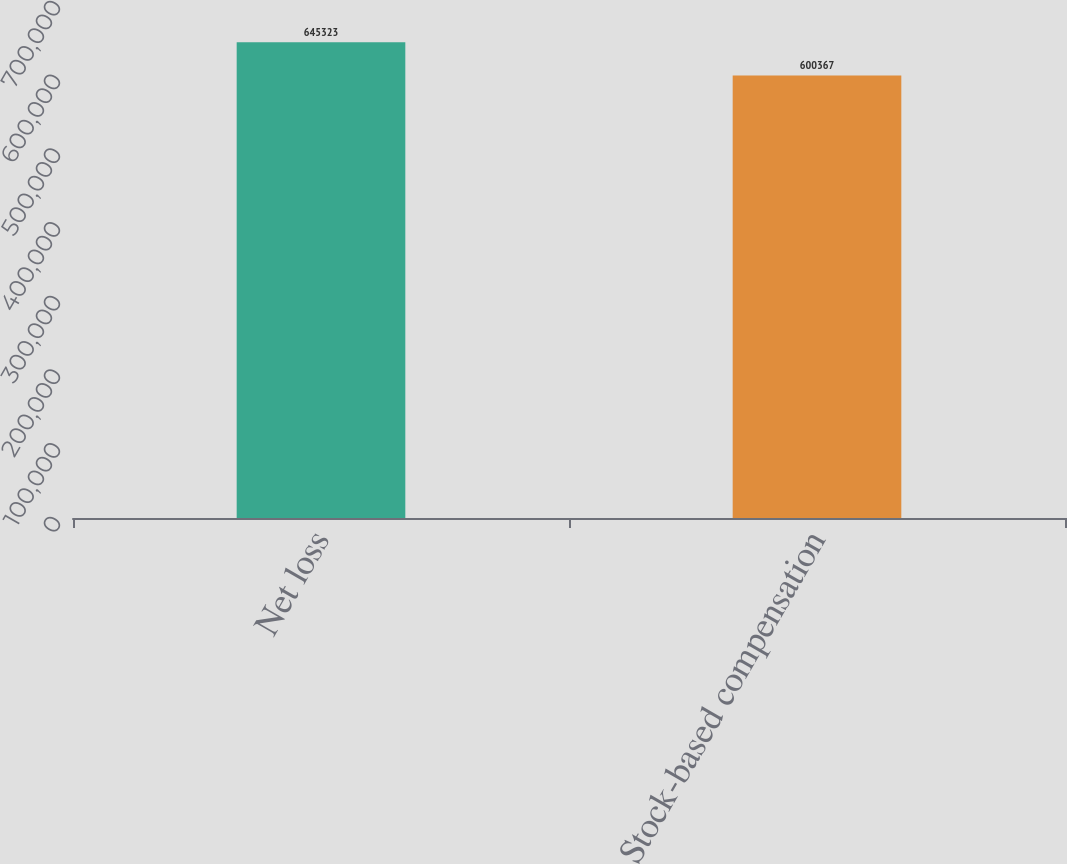Convert chart to OTSL. <chart><loc_0><loc_0><loc_500><loc_500><bar_chart><fcel>Net loss<fcel>Stock-based compensation<nl><fcel>645323<fcel>600367<nl></chart> 